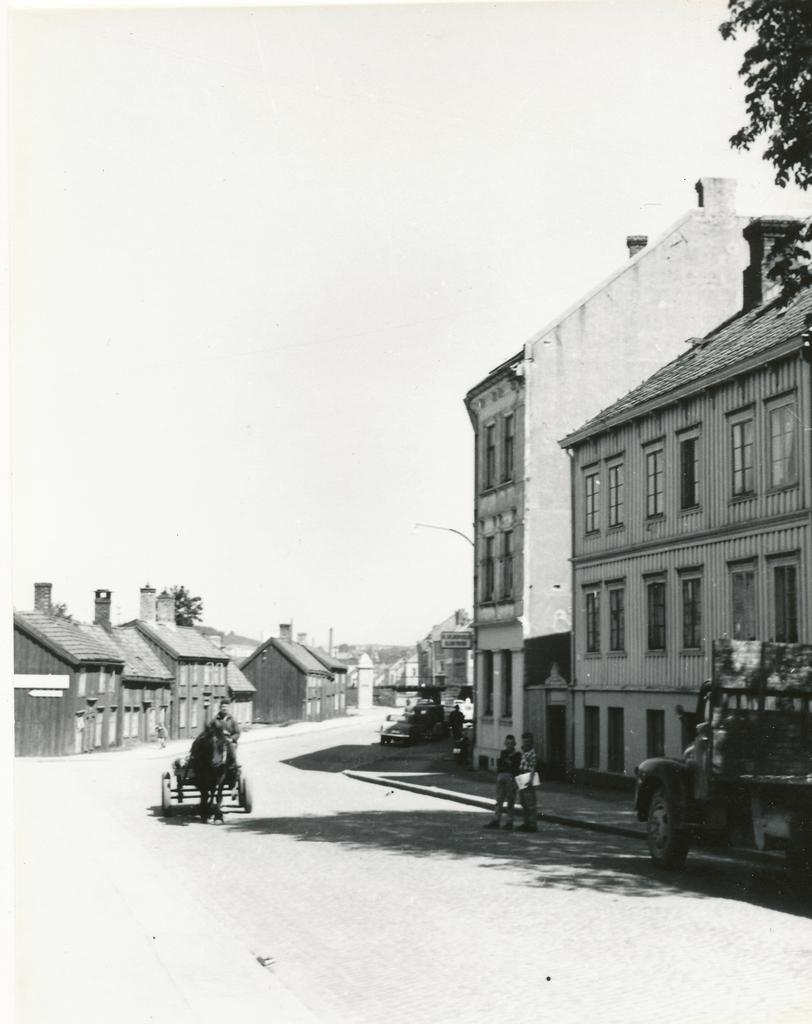What type of structure is visible in the image? There is a building in the image. Are there any residential structures in the image? Yes, there are houses in the image. What animal can be seen in the image? There is a horse in the image. Who is on the horse? A man is sitting on the horse. What is the purpose of the road in the image? The road is likely used for transportation. What type of summer activity is the man and horse participating in the image? There is no indication of a summer activity in the image, as it does not mention the season or any specific activity. How many deer can be seen in the image? There are no deer present in the image. 